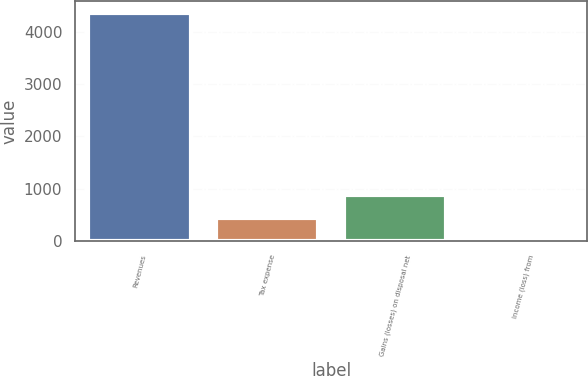Convert chart. <chart><loc_0><loc_0><loc_500><loc_500><bar_chart><fcel>Revenues<fcel>Tax expense<fcel>Gains (losses) on disposal net<fcel>Income (loss) from<nl><fcel>4367<fcel>450.2<fcel>885.4<fcel>15<nl></chart> 